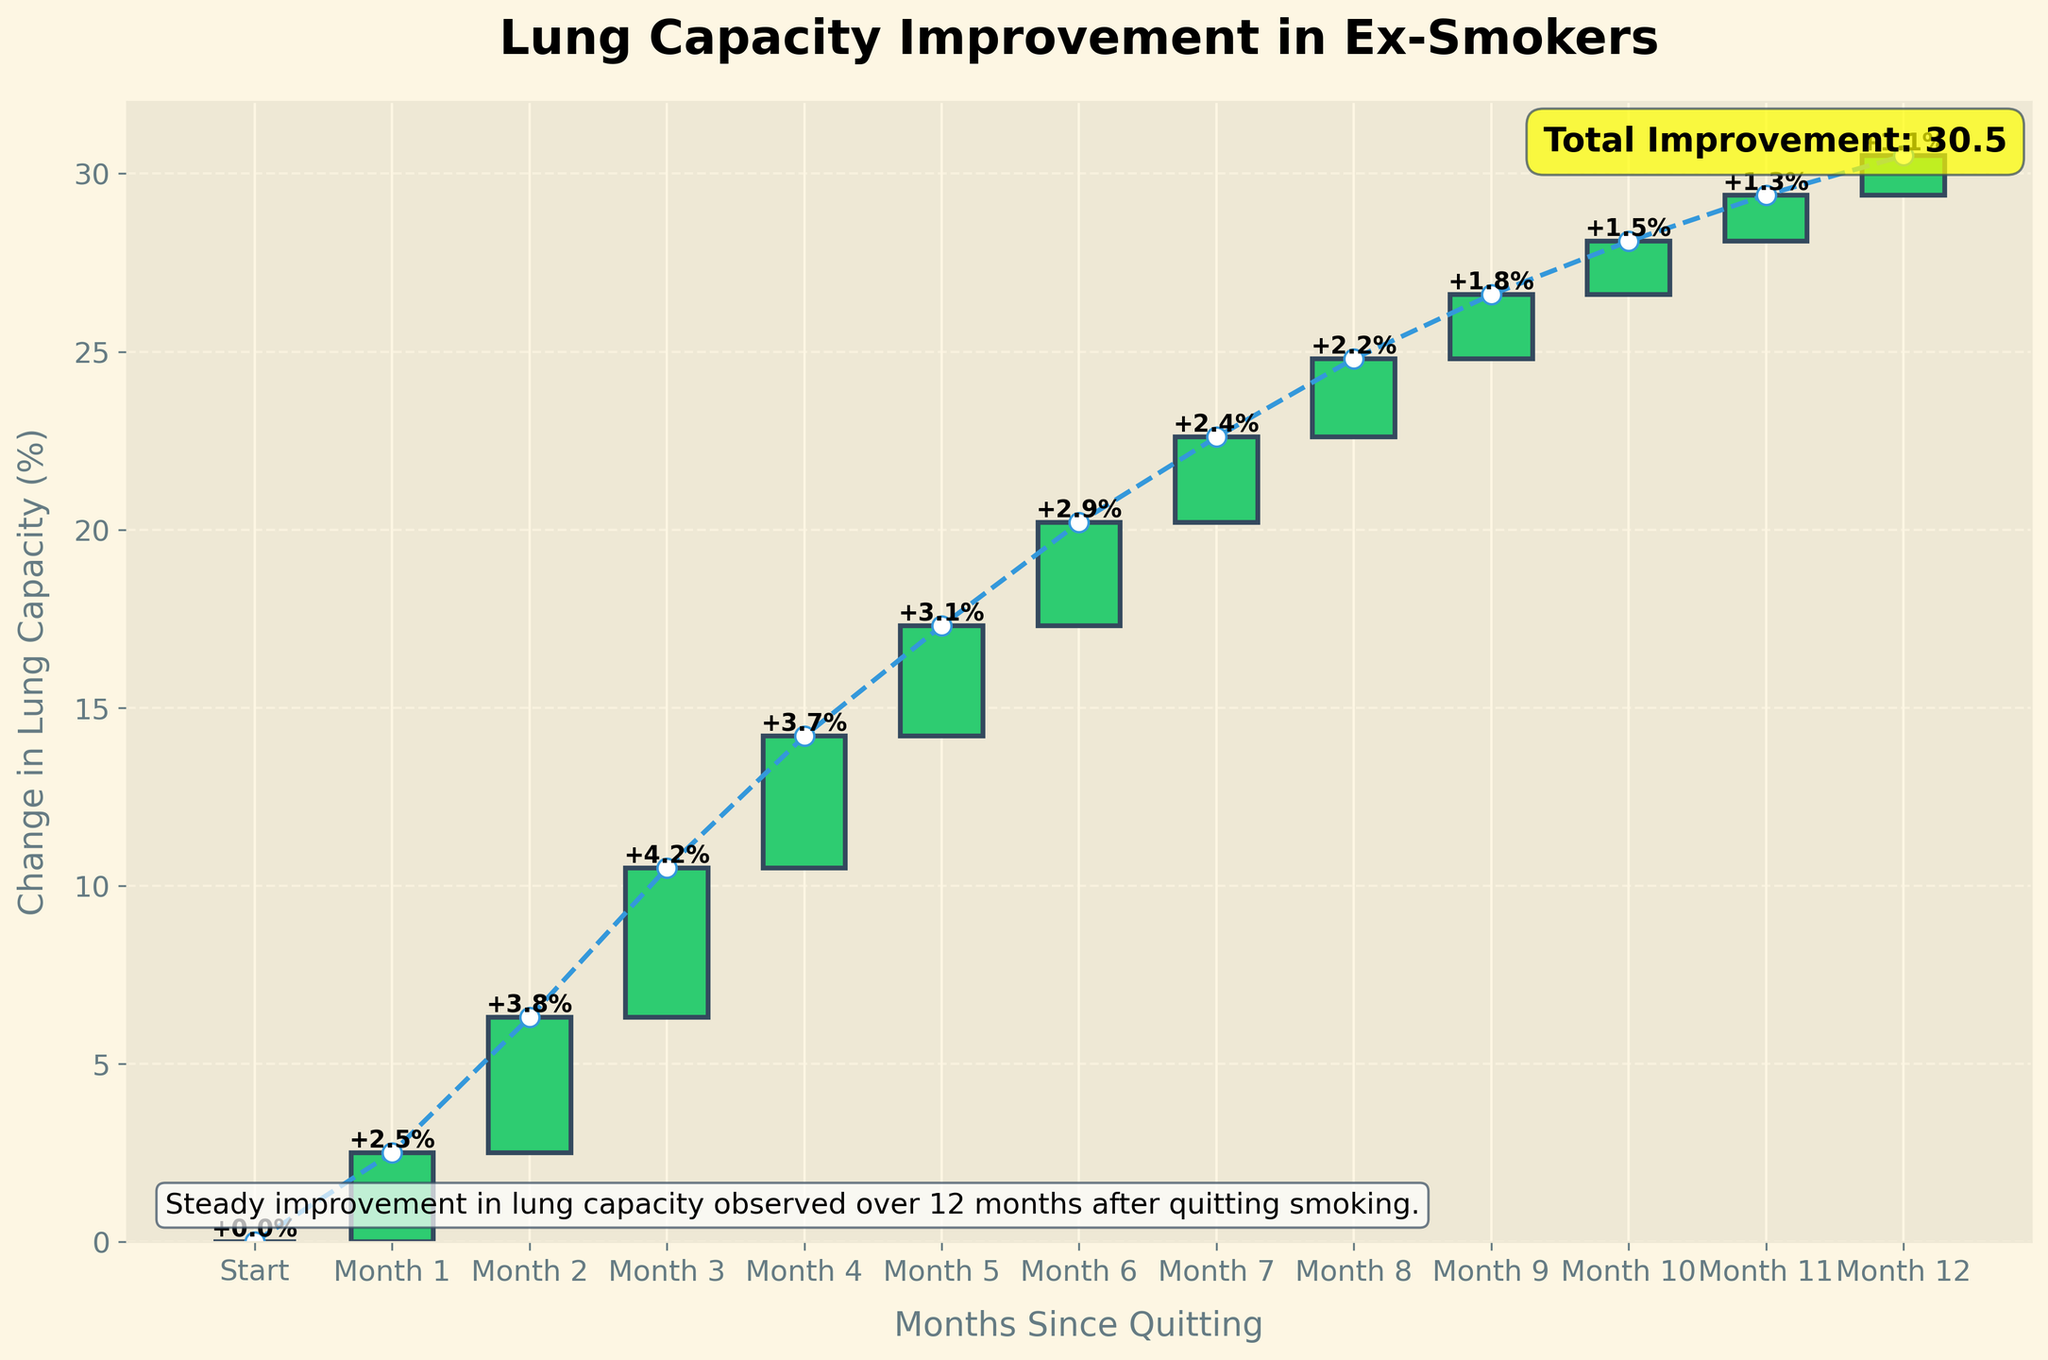What is the title of the chart? The title is prominently displayed at the top of the chart. It states "Lung Capacity Improvement in Ex-Smokers."
Answer: Lung Capacity Improvement in Ex-Smokers How much change in lung capacity is observed in the first month after quitting smoking? The label on the bar corresponding to Month 1 indicates the change in lung capacity. It shows +2.5%.
Answer: +2.5% Which month had the highest improvement in lung capacity? By comparing the height of all the bars in the chart, we can see that Month 3 has the highest bar, indicating a change of +4.2%.
Answer: Month 3 What is the cumulative change in lung capacity by the end of Month 6? Adding up the changes from Month 1 to Month 6: +2.5 + 3.8 + 4.2 + 3.7 + 3.1 + 2.9 = 20.2%. The plot line also shows this cumulative value at Month 6.
Answer: 20.2% How does the lung capacity change between Month 3 and Month 4? The bars for Month 3 and Month 4 show the respective changes of +4.2% and +3.7%. The difference in the incremental improvement is +4.2% - +3.7% = +0.5%.
Answer: +0.5% Which month shows the smallest improvement in lung capacity? By comparing the heights of all the bars, Month 12 shows the smallest improvement with a change of +1.1%.
Answer: Month 12 Describe the overall trend of lung capacity change over the 12 months Initially, the changes in lung capacity are quite significant (e.g., +4.2% in Month 3), but the improvement increments tend to decrease steadily over time, with the smallest change observed in Month 12 (+1.1%).
Answer: Decreasing increments What is the total improvement in lung capacity over the 12 months? The annotation at the bottom right of the chart indicates the total improvement. It is also visually supported by the final point of the cumulative plot line. The total improvement is 30.5%.
Answer: 30.5% How does the lung capacity improvement compare between Month 6 and Month 12? The change in Month 6 is +2.9% and in Month 12 is +1.1%. This shows that the improvement in Month 6 is significantly higher than in Month 12.
Answer: Month 6 is higher than Month 12 What additional information does the descriptive text at the bottom left of the chart provide? The descriptive text at the bottom left of the chart summarizes the general observation: "Steady improvement in lung capacity observed over 12 months after quitting smoking." This gives a qualitative insight into the pattern of improvement seen in the graph.
Answer: Steady improvement over 12 months 